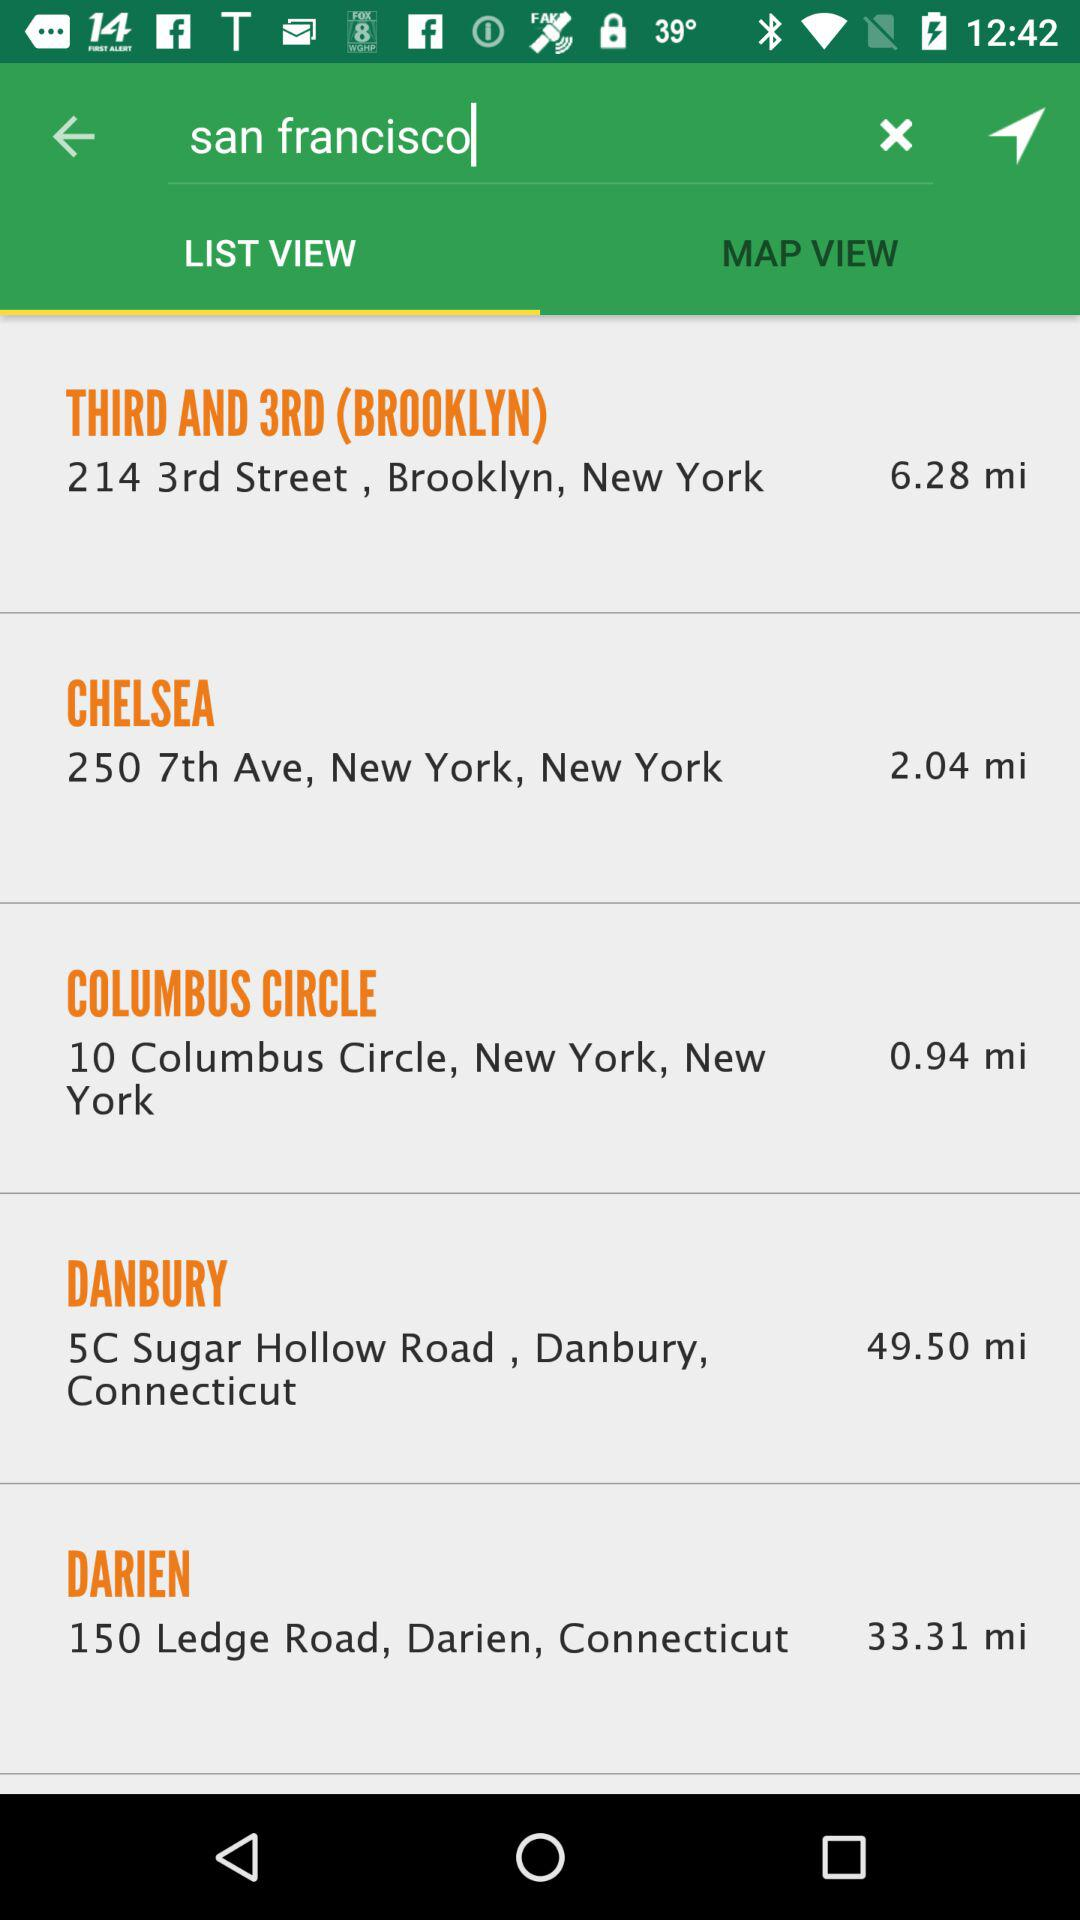How many locations are there?
Answer the question using a single word or phrase. 5 